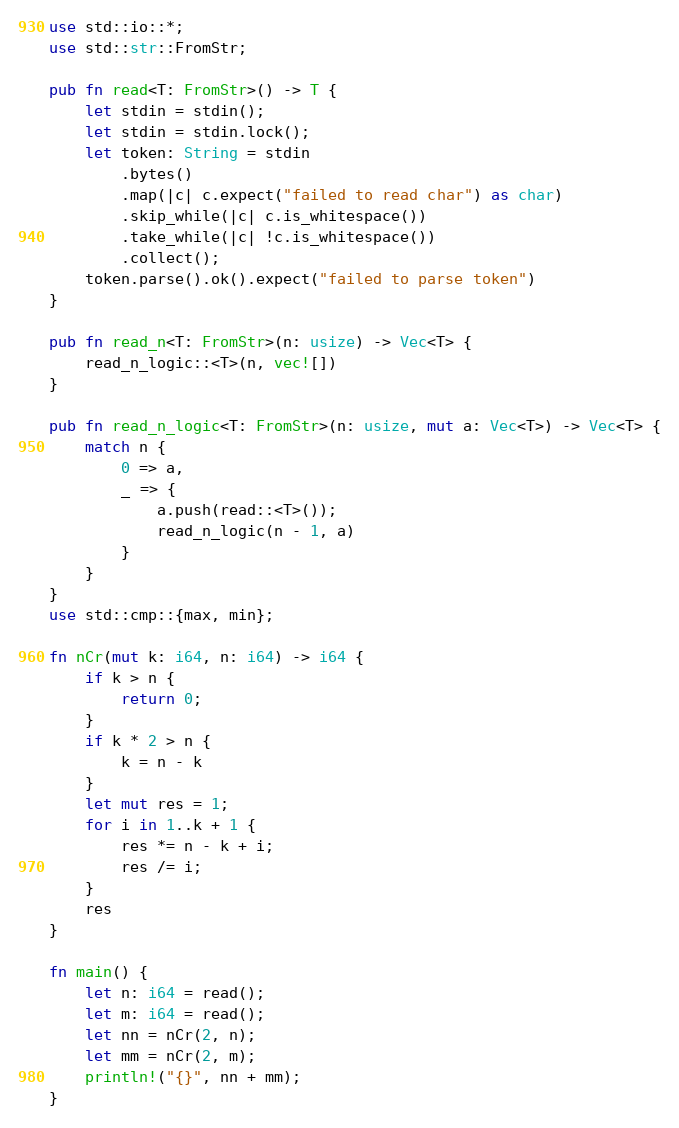Convert code to text. <code><loc_0><loc_0><loc_500><loc_500><_Rust_>use std::io::*;
use std::str::FromStr;

pub fn read<T: FromStr>() -> T {
    let stdin = stdin();
    let stdin = stdin.lock();
    let token: String = stdin
        .bytes()
        .map(|c| c.expect("failed to read char") as char)
        .skip_while(|c| c.is_whitespace())
        .take_while(|c| !c.is_whitespace())
        .collect();
    token.parse().ok().expect("failed to parse token")
}

pub fn read_n<T: FromStr>(n: usize) -> Vec<T> {
    read_n_logic::<T>(n, vec![])
}

pub fn read_n_logic<T: FromStr>(n: usize, mut a: Vec<T>) -> Vec<T> {
    match n {
        0 => a,
        _ => {
            a.push(read::<T>());
            read_n_logic(n - 1, a)
        }
    }
}
use std::cmp::{max, min};

fn nCr(mut k: i64, n: i64) -> i64 {
    if k > n {
        return 0;
    }
    if k * 2 > n {
        k = n - k
    }
    let mut res = 1;
    for i in 1..k + 1 {
        res *= n - k + i;
        res /= i;
    }
    res
}

fn main() {
    let n: i64 = read();
    let m: i64 = read();
    let nn = nCr(2, n);
    let mm = nCr(2, m);
    println!("{}", nn + mm);
}
</code> 